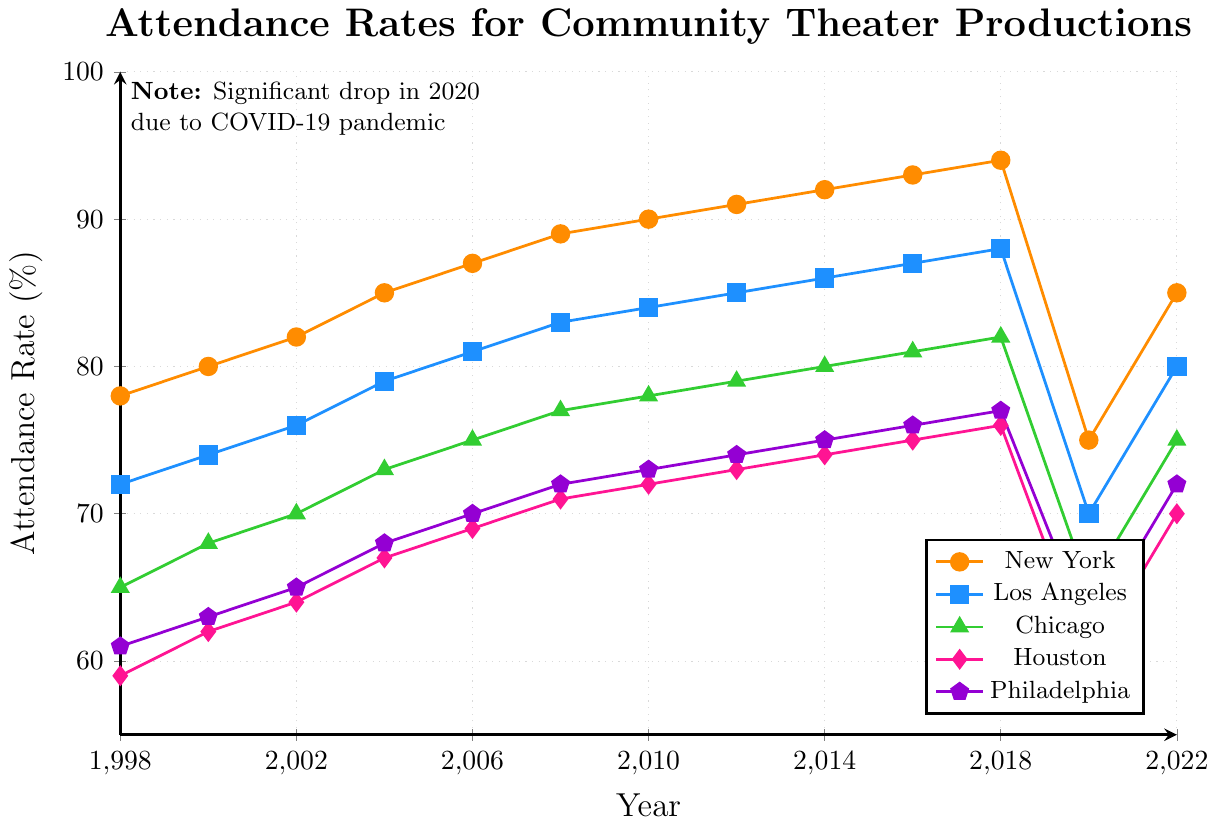What was the highest attendance rate recorded for New York? The data shows the yearly attendance rates for New York. The highest value in the New York series is the maximum rate recorded.
Answer: 94 What year did Los Angeles have an attendance rate equal to Philadelphia's rate in 2022? Los Angeles's attendance rate must be matched to Philadelphia's 2022 rate of 72%. The plot shows that in 2010, Los Angeles had an attendance rate corresponding to 72%.
Answer: 2010 By how much did Chicago's attendance rate drop from 2018 to 2020? Chicago's attendance rate was 82% in 2018 and dropped to 65% in 2020. The difference is calculated as 82% - 65%.
Answer: 17% Calculate the average attendance rate for Houston from 2000 to 2008. For this period, the data points are: 62% (2000), 64% (2002), 67% (2004), 69% (2006), 71% (2008). Sum them up and divide by the number of years: (62 + 64 + 67 + 69 + 71) / 5.
Answer: 66.6% Which city had the least variability in attendance rates from 1998 to 2018? Variability can be measured by the differences between the highest and lowest attendance rates during this period. Calculate the difference for each city:  
New York: 94% - 78% = 16%
Los Angeles: 88% - 72% = 16%
Chicago: 82% - 65% = 17%
Houston: 76% - 59% = 17%
Philadelphia: 77% - 61% = 16%  
New York, Los Angeles, and Philadelphia have the least variability (16%).
Answer: New York, Los Angeles, Philadelphia Which city had the highest attendance drop between 2018 and 2020? Check the attendance rates in 2018 and 2020 for all cities, then calculate the difference:  
New York: 94% - 75% = 19%
Los Angeles: 88% - 70% = 18%
Chicago: 82% - 65% = 17%
Houston: 76% - 60% = 16%
Philadelphia: 77% - 62% = 15%  
New York had the highest drop at 19%.
Answer: New York Which city showed the most significant recovery between 2020 and 2022? Calculate the increase in attendance rates between 2020 and 2022 for each city:  
New York: 85% - 75% = 10%
Los Angeles: 80% - 70% = 10%
Chicago: 75% - 65% = 10%
Houston: 70% - 60% = 10%
Philadelphia: 72% - 62% = 10%  
All cities show the same increase of 10%.
Answer: New York, Los Angeles, Chicago, Houston, Philadelphia What color represents the attendance rates of Chicago in the plot? Identify the color used for the Chicago line by checking the color of the triangles in the legend.
Answer: Green In which year did New York hit an attendance rate of over 90% for the first time? Trace the New York data points in the plot and find the earliest year where the attendance rate is above 90%. This is first achieved in 2010.
Answer: 2010 